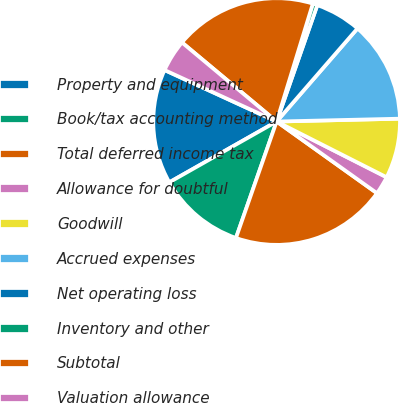Convert chart to OTSL. <chart><loc_0><loc_0><loc_500><loc_500><pie_chart><fcel>Property and equipment<fcel>Book/tax accounting method<fcel>Total deferred income tax<fcel>Allowance for doubtful<fcel>Goodwill<fcel>Accrued expenses<fcel>Net operating loss<fcel>Inventory and other<fcel>Subtotal<fcel>Valuation allowance<nl><fcel>15.06%<fcel>11.45%<fcel>20.48%<fcel>2.41%<fcel>7.83%<fcel>13.25%<fcel>6.03%<fcel>0.61%<fcel>18.67%<fcel>4.22%<nl></chart> 